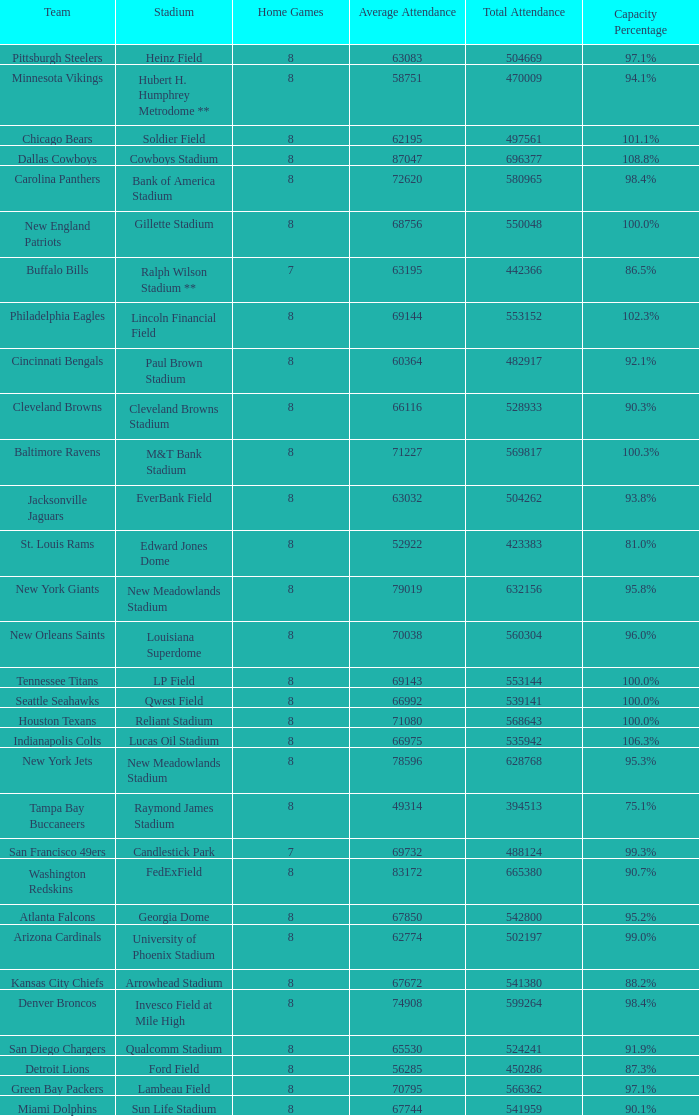What was the capacity percentage when attendance was 71080? 100.0%. 